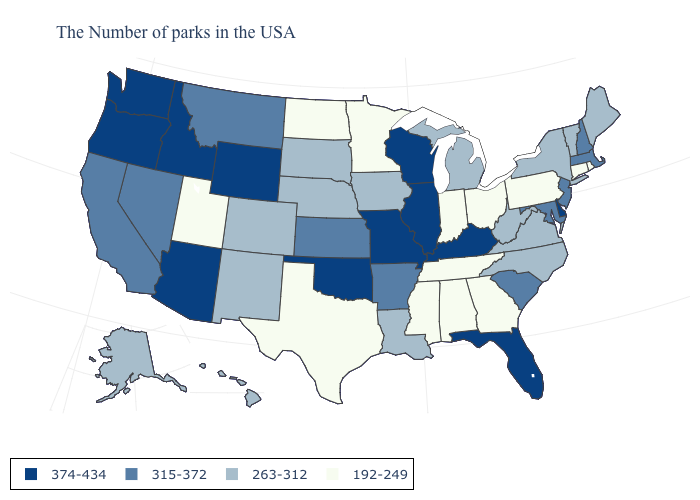What is the lowest value in the West?
Keep it brief. 192-249. What is the value of North Dakota?
Concise answer only. 192-249. Among the states that border Massachusetts , which have the lowest value?
Short answer required. Rhode Island, Connecticut. Name the states that have a value in the range 315-372?
Answer briefly. Massachusetts, New Hampshire, New Jersey, Maryland, South Carolina, Arkansas, Kansas, Montana, Nevada, California. What is the value of Wisconsin?
Write a very short answer. 374-434. Name the states that have a value in the range 192-249?
Quick response, please. Rhode Island, Connecticut, Pennsylvania, Ohio, Georgia, Indiana, Alabama, Tennessee, Mississippi, Minnesota, Texas, North Dakota, Utah. Which states hav the highest value in the West?
Keep it brief. Wyoming, Arizona, Idaho, Washington, Oregon. Does Idaho have the highest value in the USA?
Keep it brief. Yes. Does New York have the lowest value in the Northeast?
Keep it brief. No. Does Mississippi have a higher value than Kansas?
Short answer required. No. Name the states that have a value in the range 263-312?
Quick response, please. Maine, Vermont, New York, Virginia, North Carolina, West Virginia, Michigan, Louisiana, Iowa, Nebraska, South Dakota, Colorado, New Mexico, Alaska, Hawaii. Name the states that have a value in the range 374-434?
Be succinct. Delaware, Florida, Kentucky, Wisconsin, Illinois, Missouri, Oklahoma, Wyoming, Arizona, Idaho, Washington, Oregon. Name the states that have a value in the range 192-249?
Write a very short answer. Rhode Island, Connecticut, Pennsylvania, Ohio, Georgia, Indiana, Alabama, Tennessee, Mississippi, Minnesota, Texas, North Dakota, Utah. Does Florida have the lowest value in the South?
Write a very short answer. No. Name the states that have a value in the range 192-249?
Write a very short answer. Rhode Island, Connecticut, Pennsylvania, Ohio, Georgia, Indiana, Alabama, Tennessee, Mississippi, Minnesota, Texas, North Dakota, Utah. 